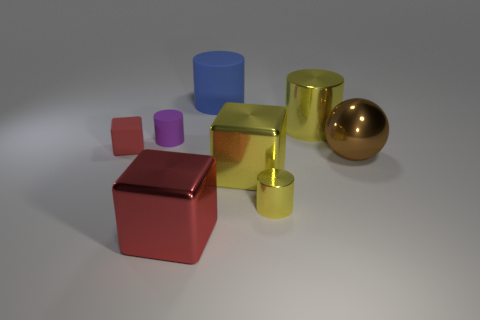Do the tiny shiny cylinder and the big shiny cylinder have the same color?
Keep it short and to the point. Yes. There is a purple cylinder that is made of the same material as the tiny block; what is its size?
Offer a very short reply. Small. What is the color of the large object that is both right of the yellow shiny cube and behind the brown metallic thing?
Keep it short and to the point. Yellow. How many blue matte cylinders are the same size as the shiny ball?
Provide a short and direct response. 1. What is the size of the other metallic cylinder that is the same color as the big shiny cylinder?
Give a very brief answer. Small. There is a cube that is both on the right side of the small red thing and to the left of the blue rubber object; how big is it?
Your answer should be very brief. Large. There is a small rubber thing behind the small thing left of the small purple rubber object; what number of yellow shiny objects are on the left side of it?
Your answer should be compact. 0. Are there any small metallic cylinders of the same color as the big metallic cylinder?
Offer a very short reply. Yes. What is the color of the metallic cylinder that is the same size as the brown shiny thing?
Provide a succinct answer. Yellow. The red thing in front of the large yellow thing that is on the left side of the yellow shiny object behind the large yellow block is what shape?
Your response must be concise. Cube. 